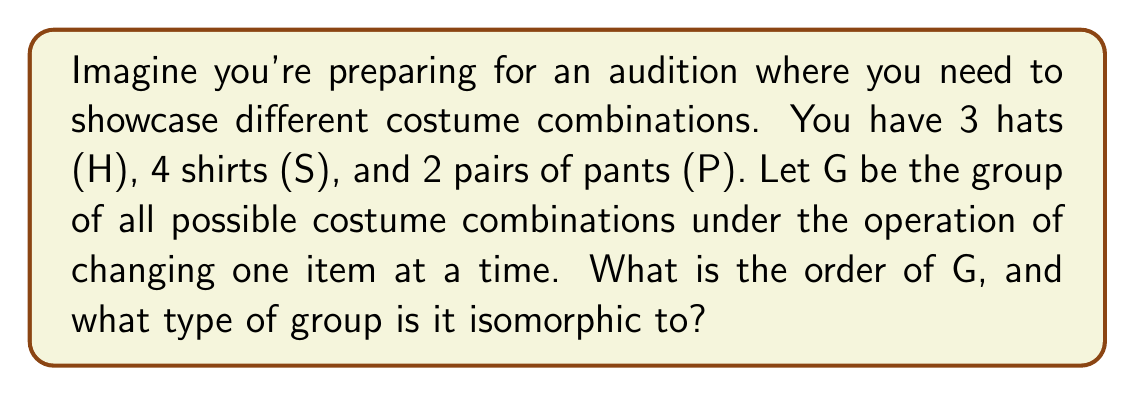Help me with this question. Let's approach this step-by-step:

1) First, we need to determine the total number of possible costume combinations. This can be done using the multiplication principle:

   Number of combinations = $3 \times 4 \times 2 = 24$

2) Each element in the group G represents a complete costume (hat, shirt, pants). The operation in this group is changing one item of clothing at a time.

3) The order of a group is the number of elements in the group. Therefore, the order of G is 24.

4) To determine what type of group G is isomorphic to, we need to consider its properties:

   a) The group is finite with 24 elements.
   b) Changing one item of clothing and then changing it back results in the original costume, so each operation is its own inverse.
   c) The operations are associative (the order of applying changes doesn't matter).
   d) There is an identity element (not changing any item of clothing).

5) These properties match those of the direct product of cyclic groups:

   $$G \cong C_3 \times C_4 \times C_2$$

   Where $C_n$ represents a cyclic group of order n.

6) This is because:
   - Changing hats forms a cycle of order 3
   - Changing shirts forms a cycle of order 4
   - Changing pants forms a cycle of order 2

7) The direct product of these cyclic groups gives us all possible combinations, which is isomorphic to our costume group G.
Answer: The order of G is 24, and G is isomorphic to $C_3 \times C_4 \times C_2$. 